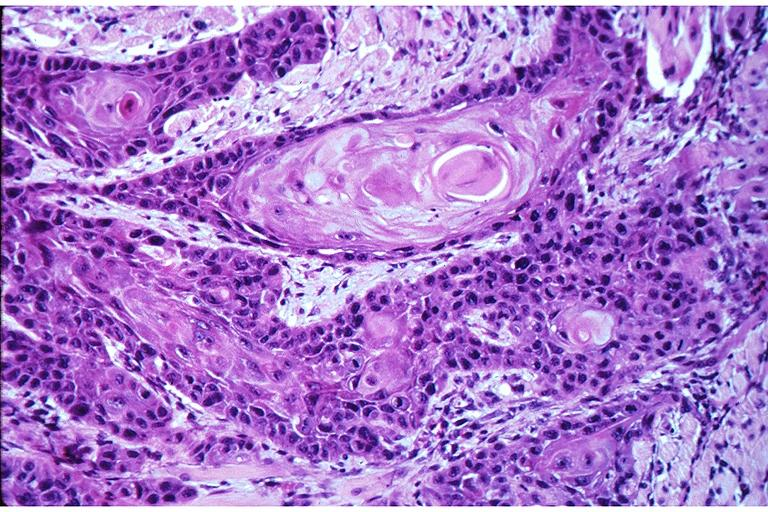what does this image show?
Answer the question using a single word or phrase. Squamous cell carcinoma 